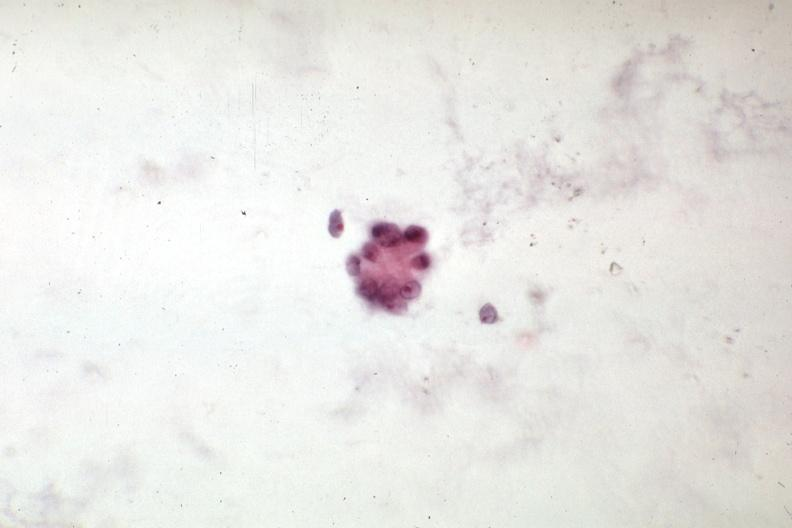what is present?
Answer the question using a single word or phrase. Abdomen 